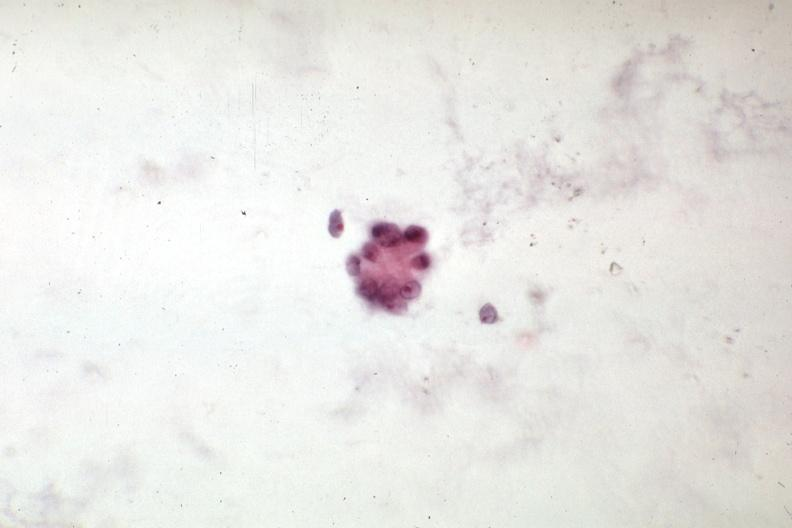what is present?
Answer the question using a single word or phrase. Abdomen 